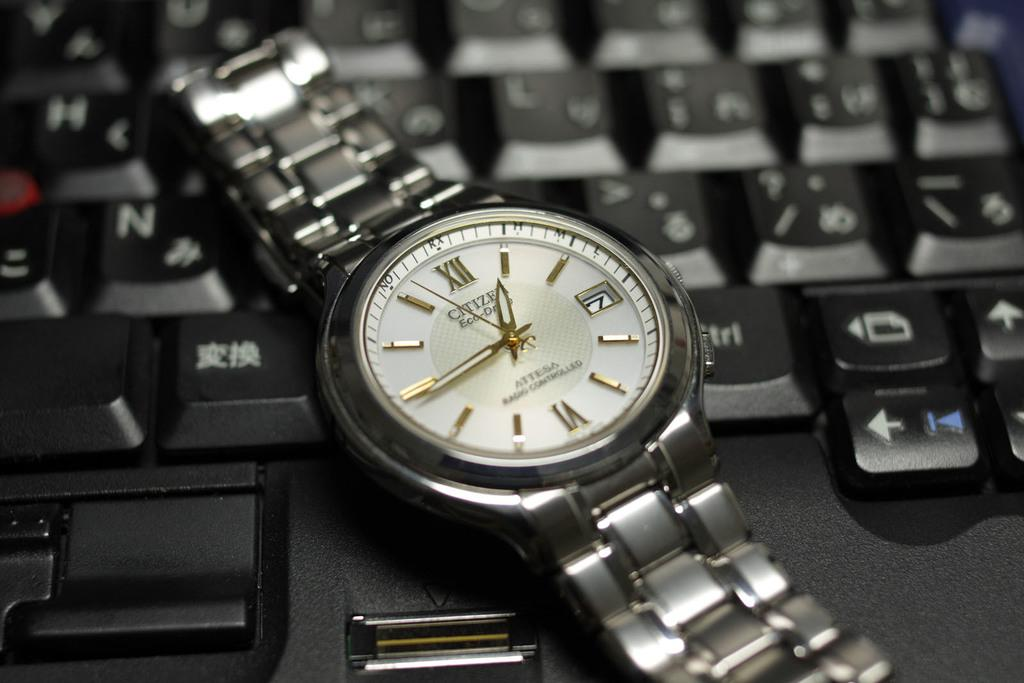<image>
Relay a brief, clear account of the picture shown. A white and silver CITIZEN watch with gold accents 